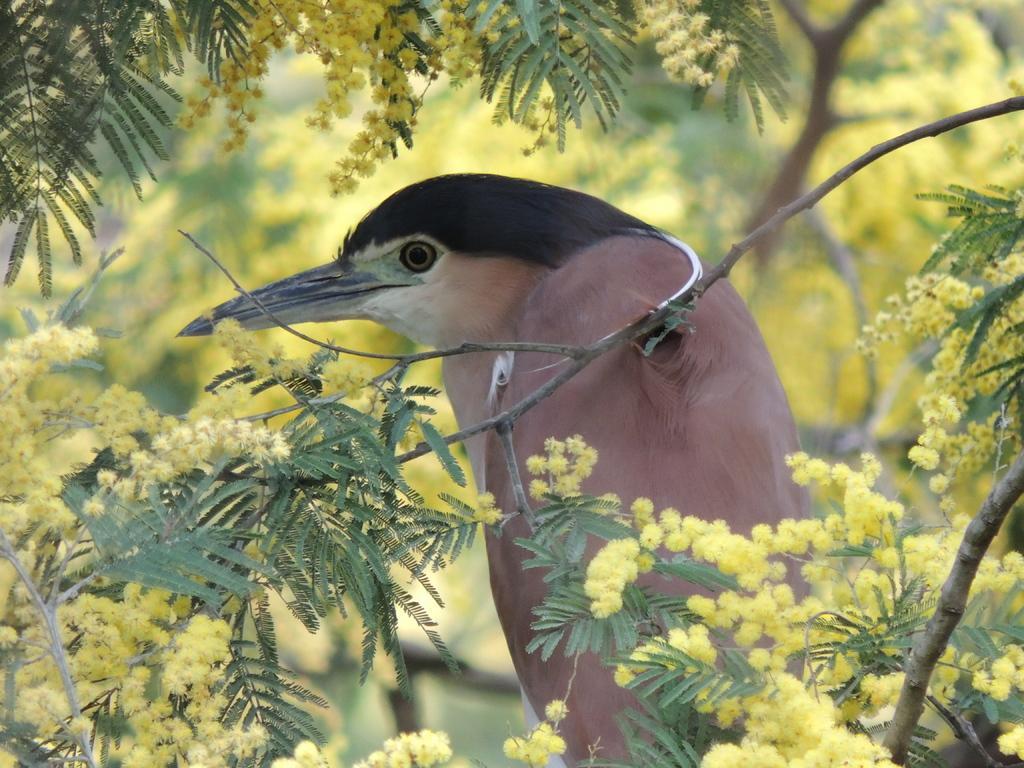Please provide a concise description of this image. In this image there is a bird. Before it there are few branches having flowers and leaves. Background there are few branches having flowers and leaves. 